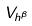<formula> <loc_0><loc_0><loc_500><loc_500>V _ { h ^ { \beta } }</formula> 